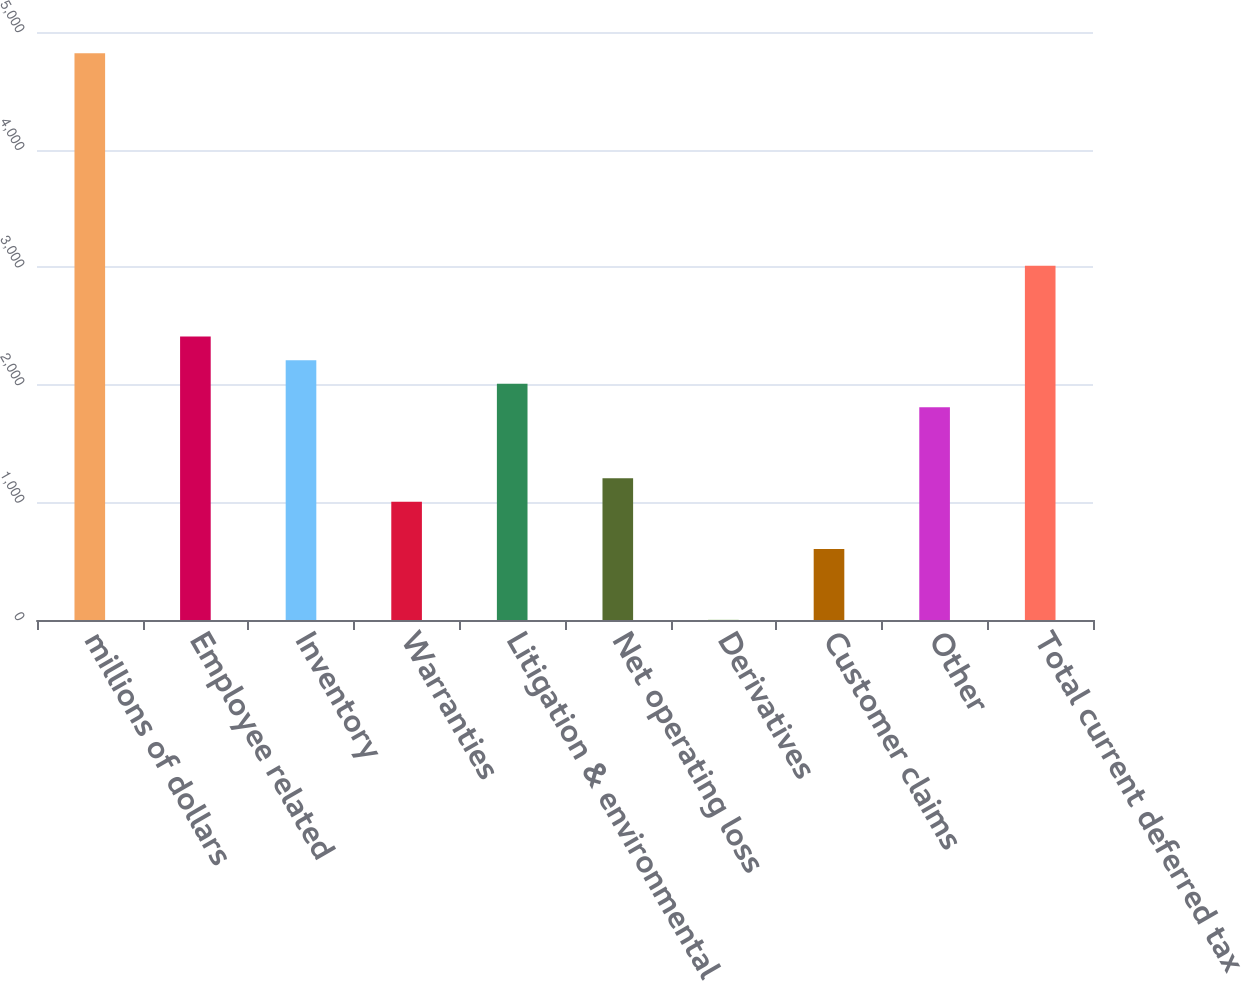<chart> <loc_0><loc_0><loc_500><loc_500><bar_chart><fcel>millions of dollars<fcel>Employee related<fcel>Inventory<fcel>Warranties<fcel>Litigation & environmental<fcel>Net operating loss<fcel>Derivatives<fcel>Customer claims<fcel>Other<fcel>Total current deferred tax<nl><fcel>4818.94<fcel>2410.42<fcel>2209.71<fcel>1005.45<fcel>2009<fcel>1206.16<fcel>1.9<fcel>604.03<fcel>1808.29<fcel>3012.55<nl></chart> 